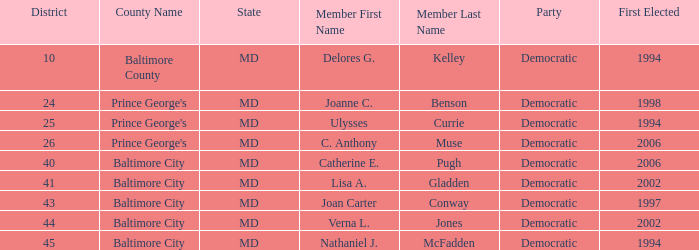What district for ulysses currie? 25.0. 